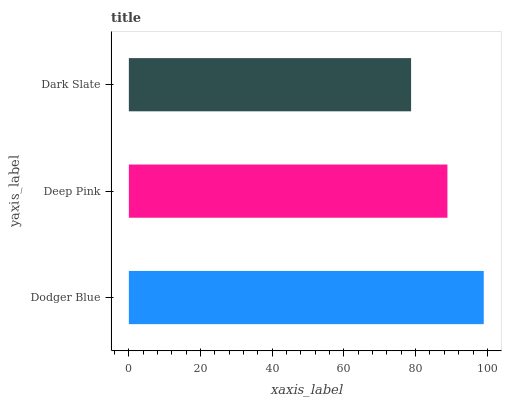Is Dark Slate the minimum?
Answer yes or no. Yes. Is Dodger Blue the maximum?
Answer yes or no. Yes. Is Deep Pink the minimum?
Answer yes or no. No. Is Deep Pink the maximum?
Answer yes or no. No. Is Dodger Blue greater than Deep Pink?
Answer yes or no. Yes. Is Deep Pink less than Dodger Blue?
Answer yes or no. Yes. Is Deep Pink greater than Dodger Blue?
Answer yes or no. No. Is Dodger Blue less than Deep Pink?
Answer yes or no. No. Is Deep Pink the high median?
Answer yes or no. Yes. Is Deep Pink the low median?
Answer yes or no. Yes. Is Dark Slate the high median?
Answer yes or no. No. Is Dodger Blue the low median?
Answer yes or no. No. 